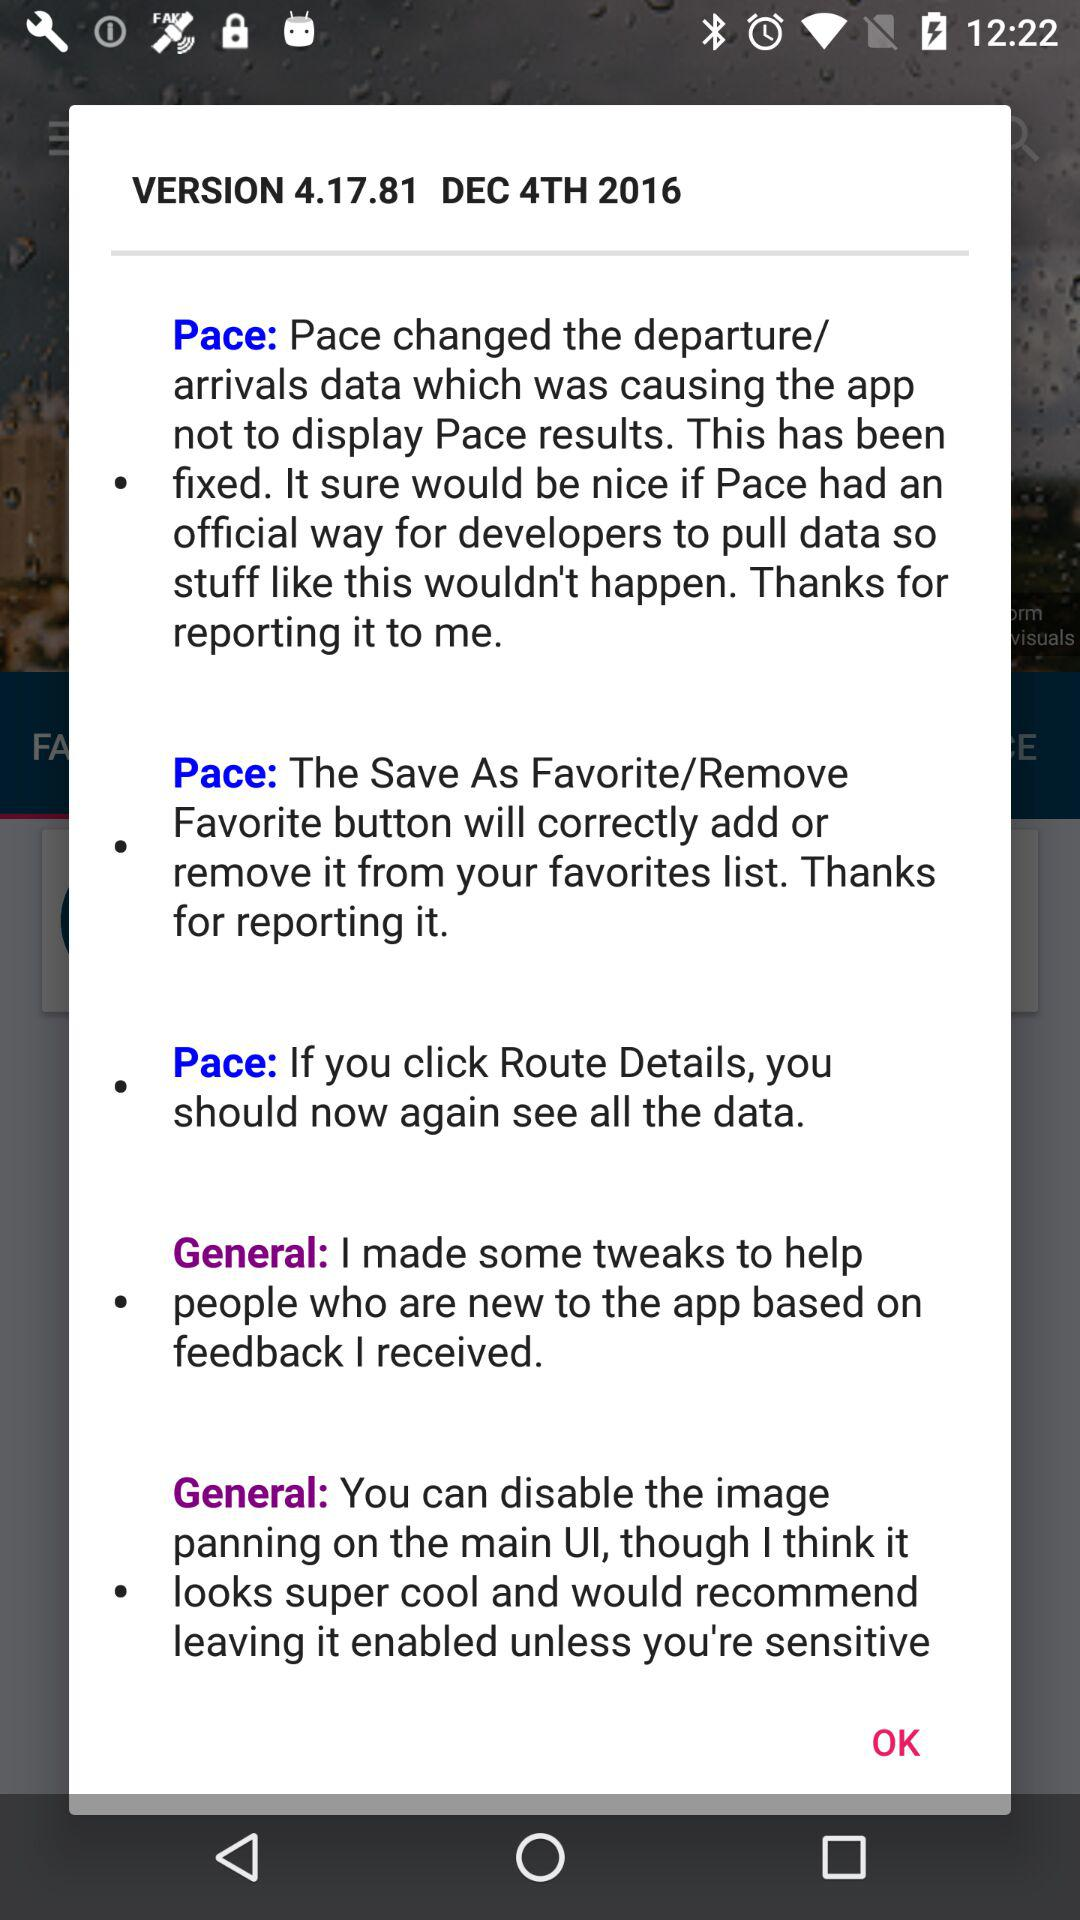What is the version number? The version number is 4.17.81. 